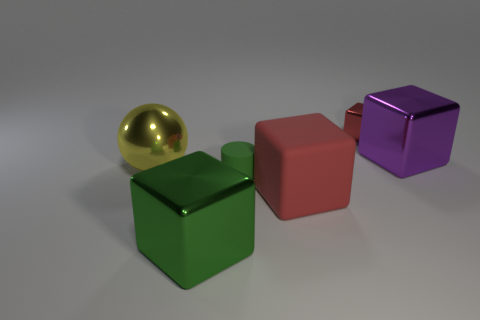Is the size of the yellow metallic thing the same as the green metal object?
Provide a succinct answer. Yes. What material is the red cube that is the same size as the yellow metallic thing?
Your answer should be very brief. Rubber. What color is the object left of the green metallic object?
Give a very brief answer. Yellow. How many purple metallic blocks are there?
Provide a succinct answer. 1. Is there a shiny cube that is to the left of the thing that is behind the large block behind the big yellow metallic sphere?
Give a very brief answer. Yes. What shape is the green thing that is the same size as the yellow ball?
Ensure brevity in your answer.  Cube. How many other objects are there of the same color as the tiny cylinder?
Offer a terse response. 1. What is the large ball made of?
Make the answer very short. Metal. What number of other objects are there of the same material as the small red thing?
Your response must be concise. 3. What size is the cube that is in front of the large yellow metallic sphere and to the right of the large green shiny object?
Your response must be concise. Large. 